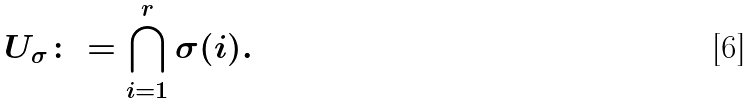Convert formula to latex. <formula><loc_0><loc_0><loc_500><loc_500>U _ { \sigma } \colon = \bigcap _ { i = 1 } ^ { r } \sigma ( i ) .</formula> 